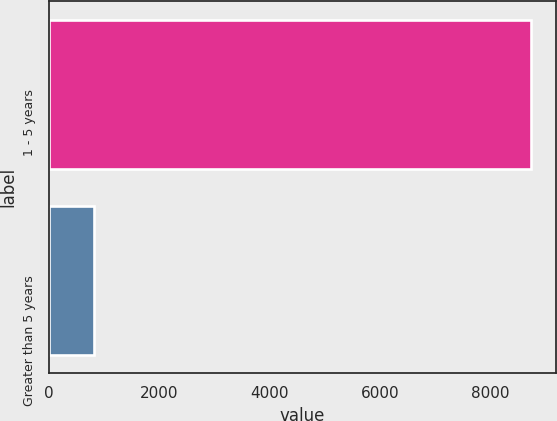<chart> <loc_0><loc_0><loc_500><loc_500><bar_chart><fcel>1 - 5 years<fcel>Greater than 5 years<nl><fcel>8747<fcel>817<nl></chart> 